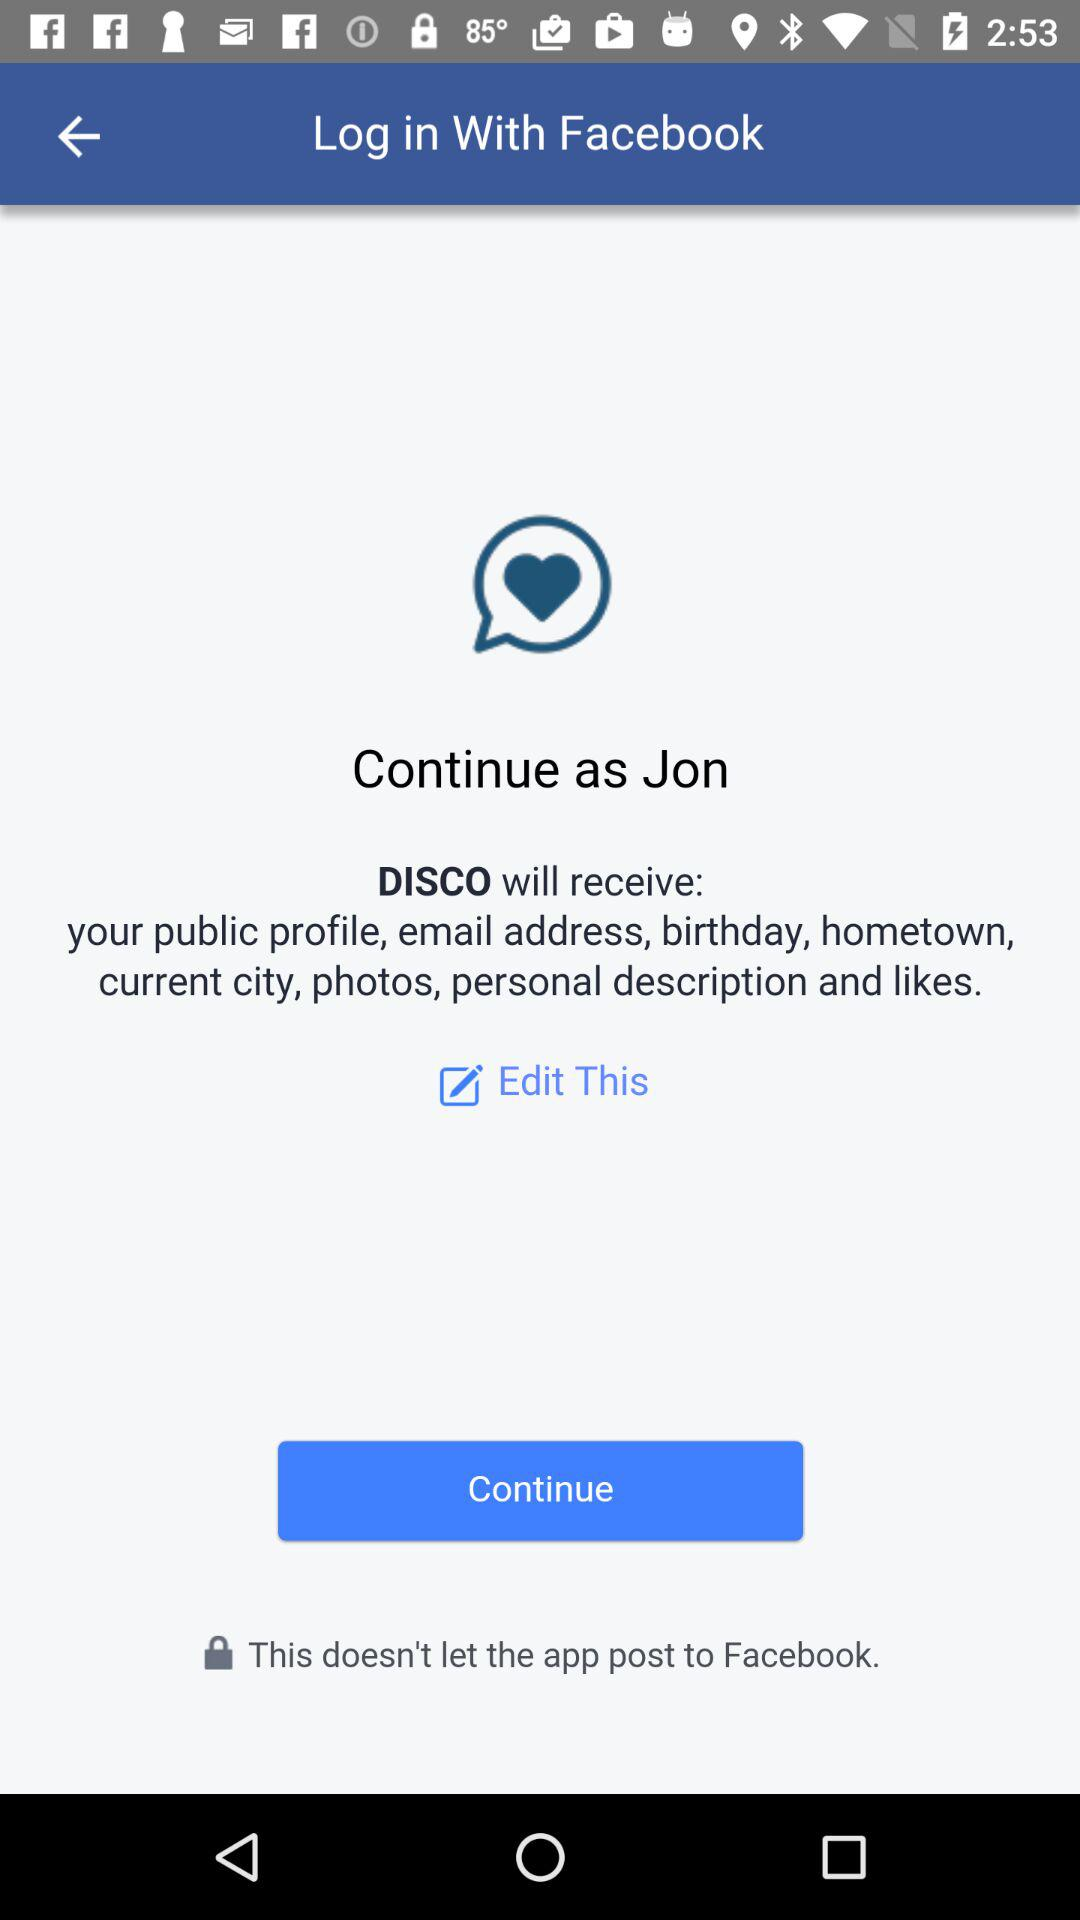What application will receive the public profile, email address, birthday, hometown, current city, photos, personal description and likes? The application "DISCO" will receive the public profile, email address, birthday, hometown, current city, photos, personal description and likes. 